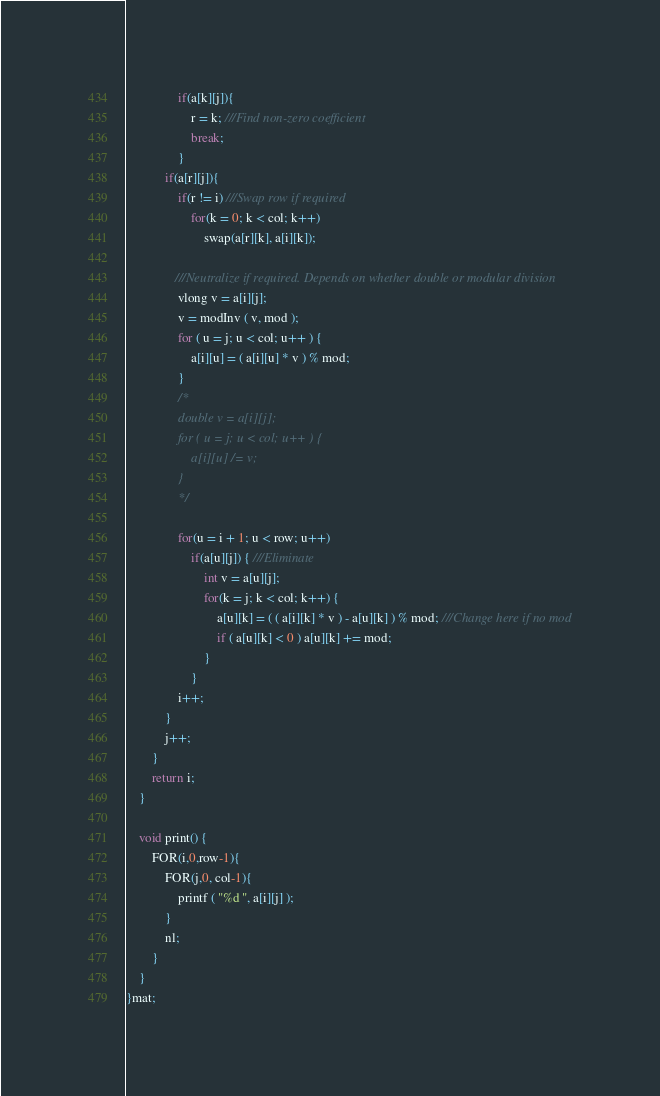<code> <loc_0><loc_0><loc_500><loc_500><_C++_>                if(a[k][j]){
                    r = k; ///Find non-zero coefficient
                    break;
                }
    		if(a[r][j]){
    			if(r != i) ///Swap row if required
    				for(k = 0; k < col; k++)
    					swap(a[r][k], a[i][k]);

               ///Neutralize if required. Depends on whether double or modular division
                vlong v = a[i][j];
                v = modInv ( v, mod );
                for ( u = j; u < col; u++ ) {
                    a[i][u] = ( a[i][u] * v ) % mod;
                }
                /*
                double v = a[i][j];
                for ( u = j; u < col; u++ ) {
                    a[i][u] /= v;
                }
                */

    			for(u = i + 1; u < row; u++)
    				if(a[u][j]) { ///Eliminate
                        int v = a[u][j];
    					for(k = j; k < col; k++) {
    						a[u][k] = ( ( a[i][k] * v ) - a[u][k] ) % mod; ///Change here if no mod
                            if ( a[u][k] < 0 ) a[u][k] += mod;
    					}
    				}
    			i++;
    		}
    		j++;
    	}
    	return i;
    }

    void print() {
        FOR(i,0,row-1){
            FOR(j,0, col-1){
                printf ( "%d ", a[i][j] );
            }
            nl;
        }
    }
}mat;
</code> 